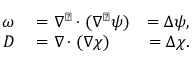Convert formula to latex. <formula><loc_0><loc_0><loc_500><loc_500>\begin{array} { r l r } { \omega } & = \nabla ^ { \perp } \cdot ( \nabla ^ { \perp } \psi ) } & { = \Delta \psi , } \\ { D } & = \nabla \cdot ( \nabla \chi ) } & { = \Delta \chi . } \end{array}</formula> 